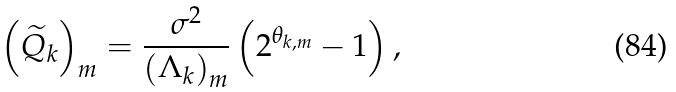<formula> <loc_0><loc_0><loc_500><loc_500>\left ( \widetilde { Q } _ { k } \right ) _ { m } = \frac { \sigma ^ { 2 } } { \left ( \Lambda _ { k } \right ) _ { m } } \left ( 2 ^ { \theta _ { k , m } } - 1 \right ) ,</formula> 